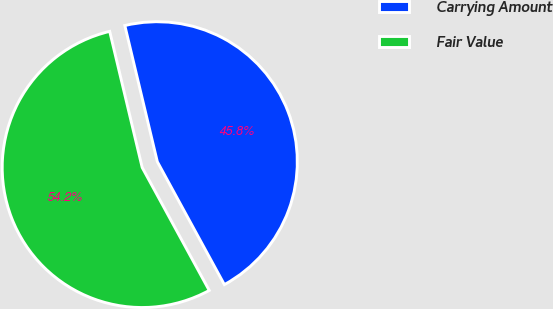Convert chart to OTSL. <chart><loc_0><loc_0><loc_500><loc_500><pie_chart><fcel>Carrying Amount<fcel>Fair Value<nl><fcel>45.78%<fcel>54.22%<nl></chart> 